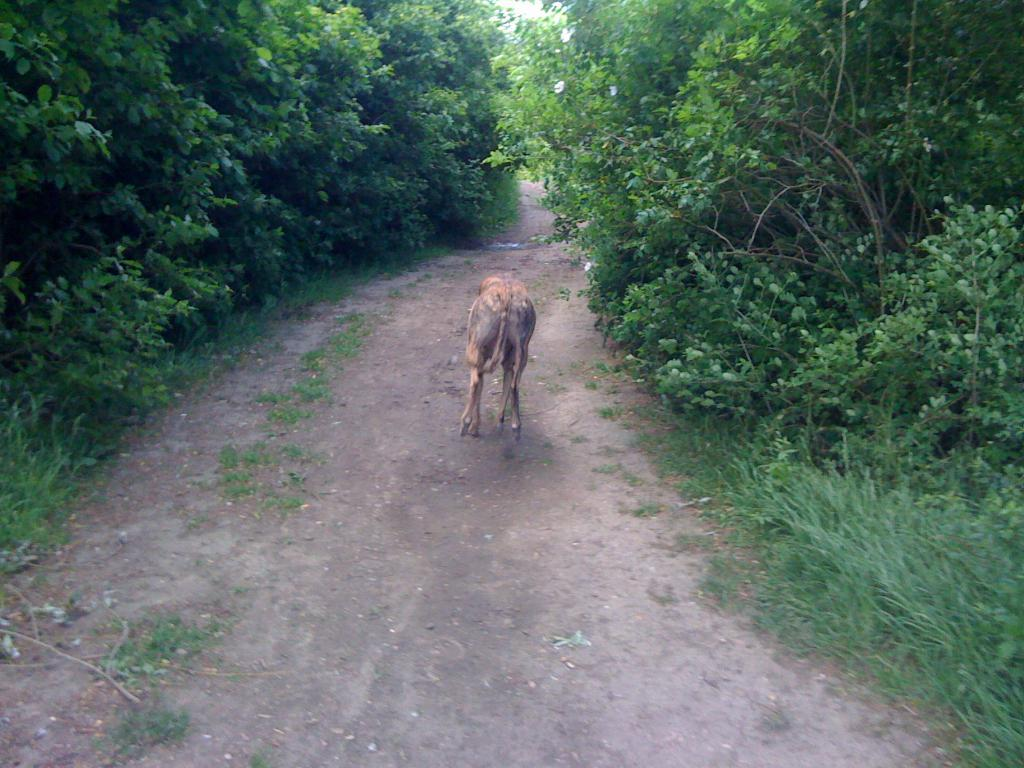What is the main feature of the image? There is a path in the image. What can be seen around the path? The path is surrounded by trees and plants. What else is present in the middle of the image? There is an animal in the middle of the image. Where is the nest located in the image? There is no nest present in the image. What is the animal doing with its tongue in the image? There is no animal using its tongue in the image. 